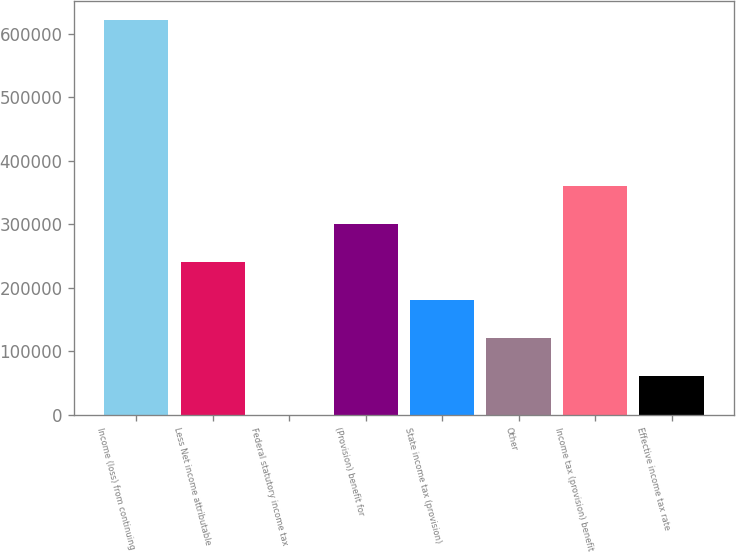Convert chart to OTSL. <chart><loc_0><loc_0><loc_500><loc_500><bar_chart><fcel>Income (loss) from continuing<fcel>Less Net income attributable<fcel>Federal statutory income tax<fcel>(Provision) benefit for<fcel>State income tax (provision)<fcel>Other<fcel>Income tax (provision) benefit<fcel>Effective income tax rate<nl><fcel>621774<fcel>240255<fcel>35<fcel>300310<fcel>180200<fcel>120145<fcel>360364<fcel>60089.9<nl></chart> 